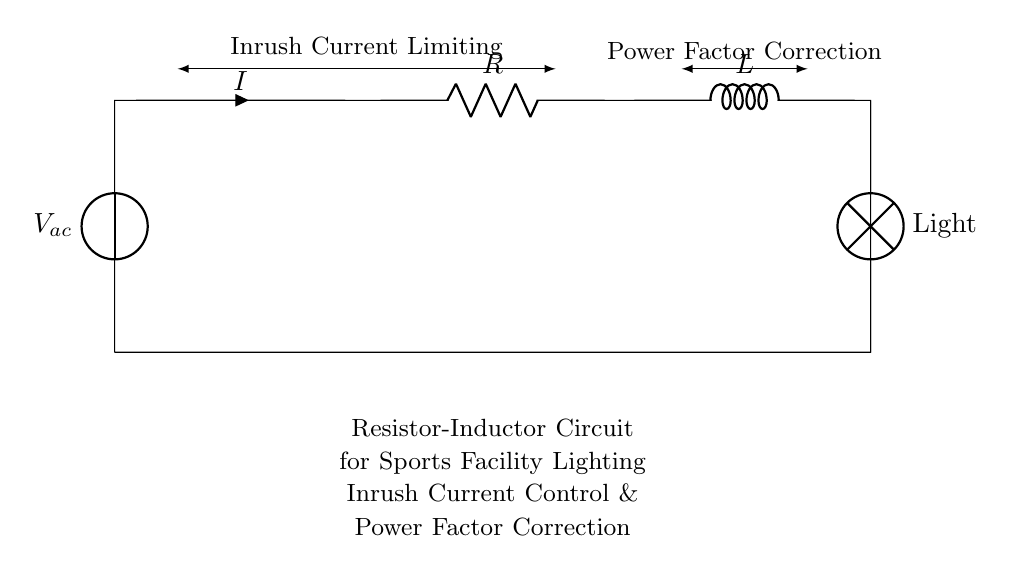What type of circuit is shown in the diagram? The circuit is a Resistor-Inductor circuit, which is characterized by the presence of a resistor and an inductor. This circuit type is mentioned in the diagram title.
Answer: Resistor-Inductor What component is used for controlling inrush current? The inductor is primarily responsible for controlling inrush current. Inductors resist changes in current, which helps to limit the initial current surge when the circuit is powered on.
Answer: Inductor What does 'R' denote in the circuit? 'R' denotes the resistor in the circuit. In the diagram, it is labeled as 'R', which indicates its role in limiting current and helping with power factor correction.
Answer: Resistor What is the purpose of the lamp in this circuit? The lamp represents the load being powered by the circuit. It is where the electrical energy is used to provide lighting, making it essential to demonstrate the effect of the resistor-inductor circuit.
Answer: Light How does this circuit accomplish power factor correction? Power factor correction in this circuit is achieved by the combination of the resistor and inductor, which helps improve the efficiency of the circuit, reducing reactive power and improving the power factor.
Answer: By R and L What is the significance of inrush current limiting in a lighting system? Inrush current limiting is significant because it prevents damage to electrical components and reduces stress on the electrical supply system by controlling the high initial current that occurs when powering the circuit.
Answer: Prevents damage What connection type is used between components in the circuit? The components in the circuit are connected in series. A series connection means that the current flows through each component consecutively, affecting the total impedance and behavior of the circuit as a whole.
Answer: Series 